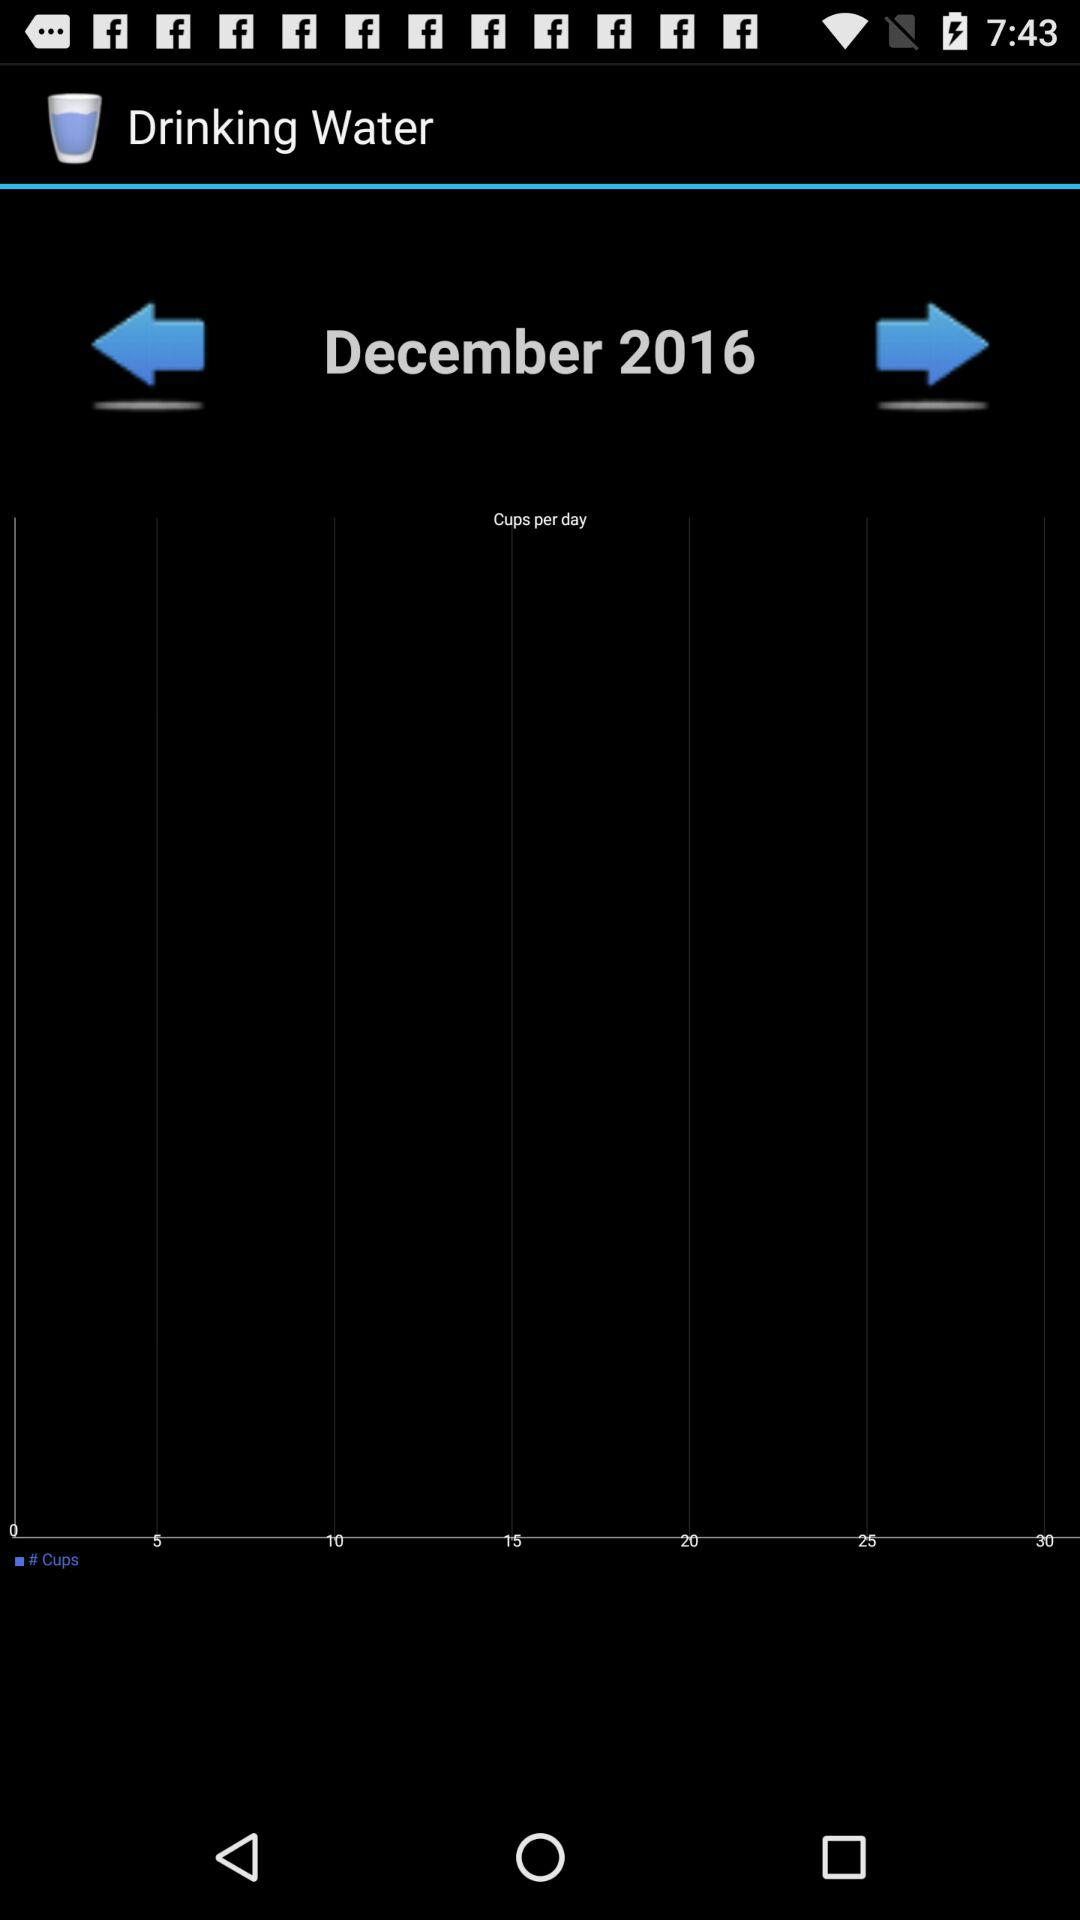What is the given month and year? The given month is December and the year is 2016. 